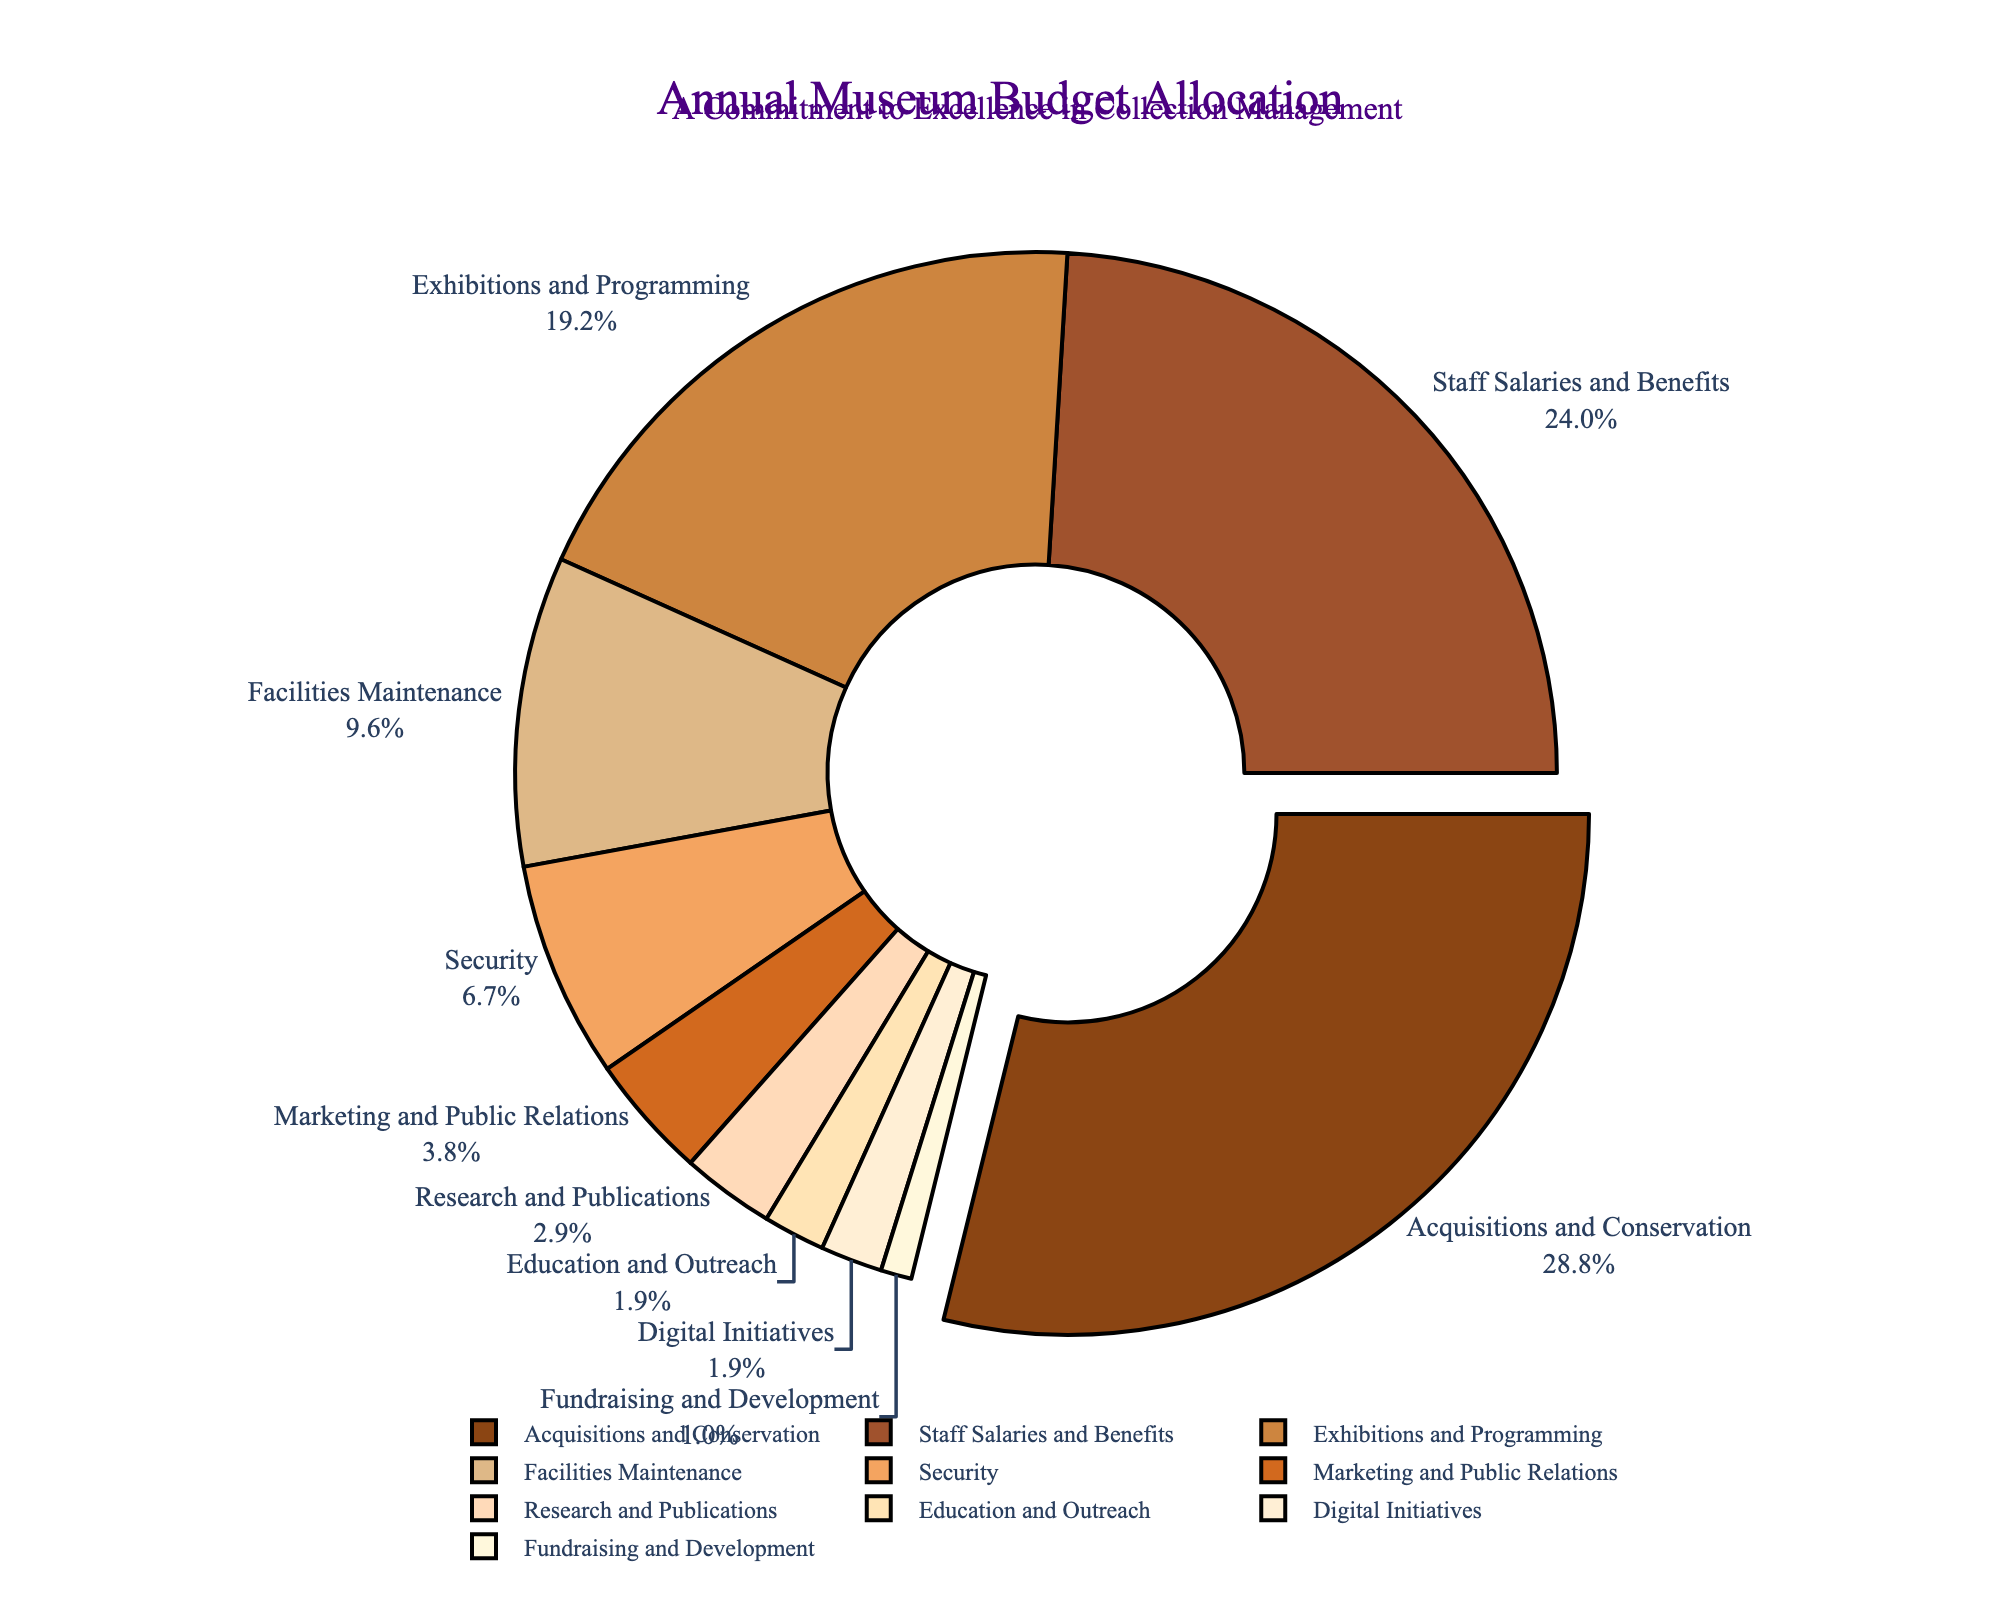Which category receives the largest portion of the annual museum budget? The category with the highest percentage value in the pie chart is the largest portion of the budget. Here, "Acquisitions and Conservation" has the highest value at 30%.
Answer: Acquisitions and Conservation What is the total percentage allocated to the top three categories? The top three categories are "Acquisitions and Conservation" (30%), "Staff Salaries and Benefits" (25%), and "Exhibitions and Programming" (20%). Adding these percentages: 30 + 25 + 20 = 75%.
Answer: 75% How does the budget for 'Marketing and Public Relations' compare to 'Security'? The pie chart shows 'Marketing and Public Relations' at 4% and 'Security' at 7%. Comparing these, 'Security' receives a higher percentage than 'Marketing and Public Relations'.
Answer: Security receives more What is the combined budget allocation for 'Education and Outreach', 'Digital Initiatives', and 'Fundraising and Development'? Summing the percentages for 'Education and Outreach' (2%), 'Digital Initiatives' (2%), and 'Fundraising and Development' (1%): 2 + 2 + 1 = 5%.
Answer: 5% Which category has the smallest budget allocation, and what is its percentage? The pie chart indicates that 'Fundraising and Development' has the smallest budget allocation at 1%.
Answer: Fundraising and Development, 1% Is the percentage allocated to 'Staff Salaries and Benefits' greater than that for 'Exhibitions and Programming'? According to the pie chart, 'Staff Salaries and Benefits' is allocated 25%, while 'Exhibitions and Programming' is allocated 20%. Therefore, 25% is greater than 20%.
Answer: Yes Which visual attribute highlights the largest budget category? The visual attribute distinguishing the largest budget category ('Acquisitions and Conservation') is that it is slightly pulled out from the pie chart.
Answer: Pulled out slice What is the total percentage allocated to categories related to direct public engagement ('Exhibitions and Programming', 'Marketing and Public Relations', 'Education and Outreach')? Summing the percentages of 'Exhibitions and Programming' (20%), 'Marketing and Public Relations' (4%), and 'Education and Outreach' (2%): 20 + 4 + 2 = 26%.
Answer: 26% Are 'Research and Publications' and 'Digital Initiatives' allocated the same percentage? From the pie chart, 'Research and Publications' is allocated 3%, while 'Digital Initiatives' is allocated 2%. Since these values are different, they are not allocated the same percentage.
Answer: No 